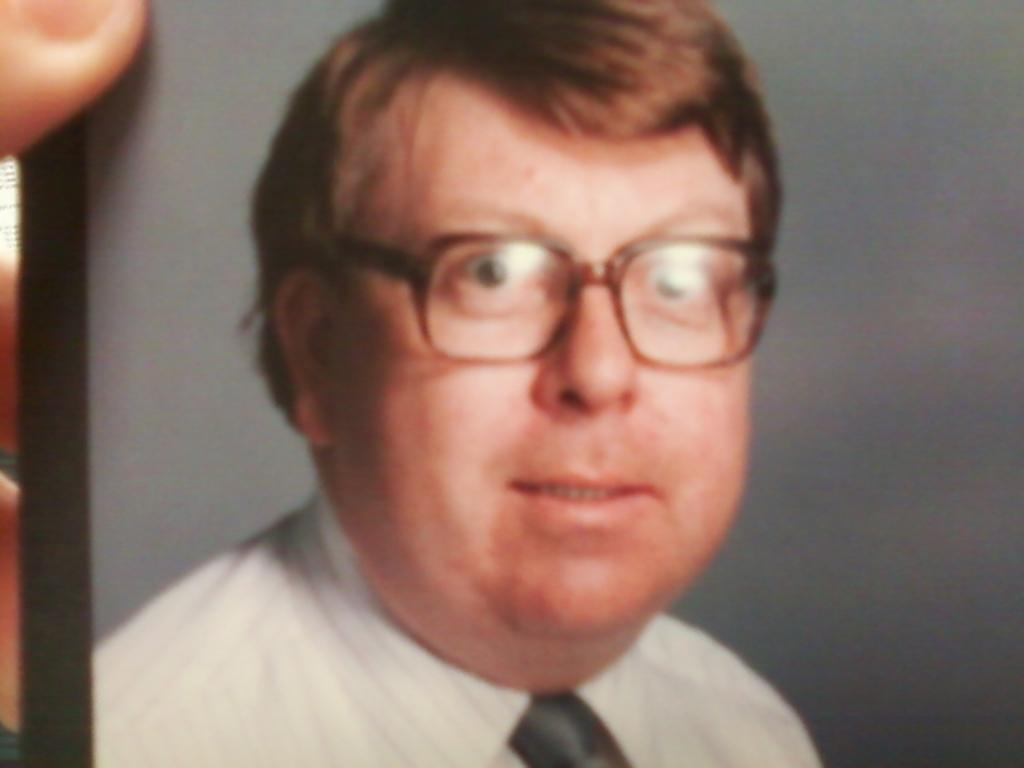What is the main subject of the image? The main subject of the image is a photo of a picture. What can be seen in the photo? There is a person in the middle of the photo. What is the person wearing? The person is wearing clothes and spectacles. What type of shade is covering the pot in the image? There is no shade or pot present in the image; it only features a photo of a picture with a person in the middle. 